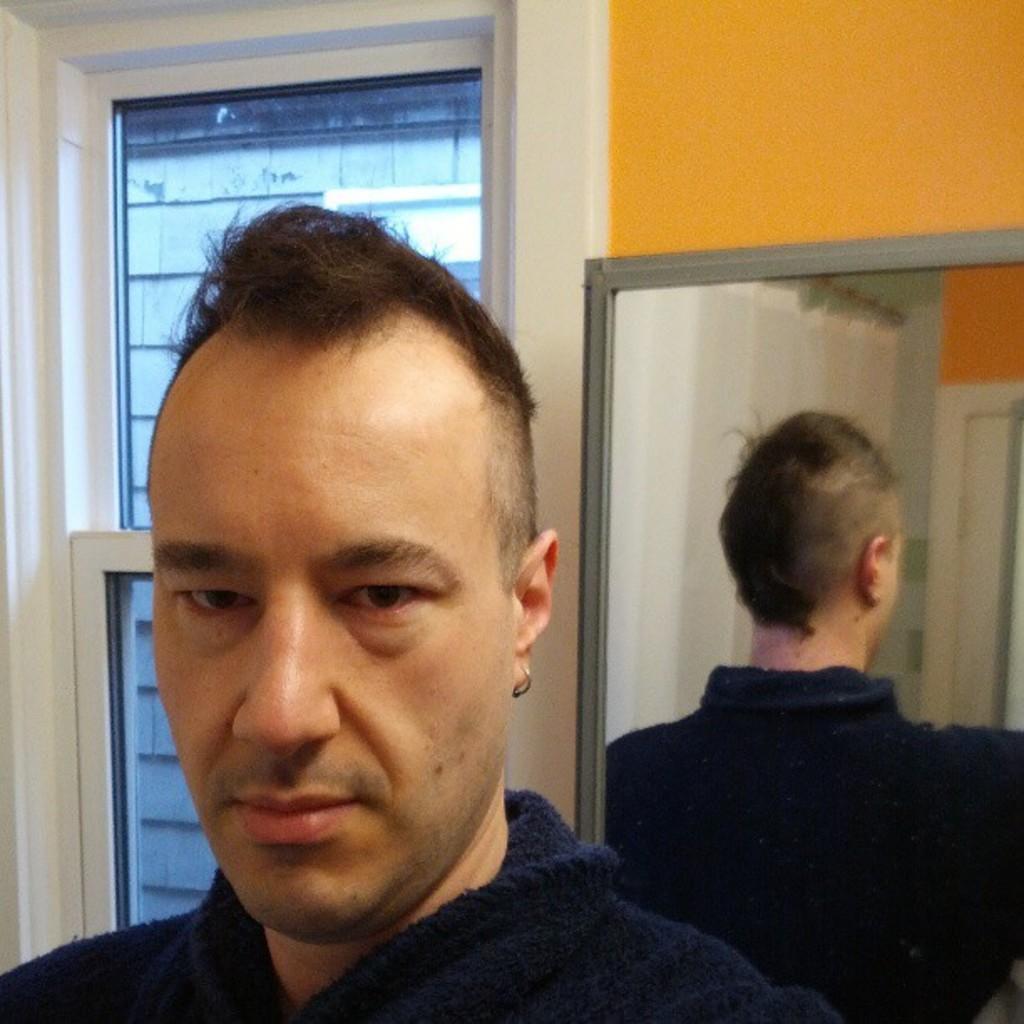Could you give a brief overview of what you see in this image? In this image, we can see a man standing, we can see the wall and there is a mirror on the wall. We can see the windows. 